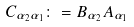Convert formula to latex. <formula><loc_0><loc_0><loc_500><loc_500>C _ { \alpha _ { 2 } \alpha _ { 1 } } \colon = B _ { \alpha _ { 2 } } A _ { \alpha _ { 1 } }</formula> 